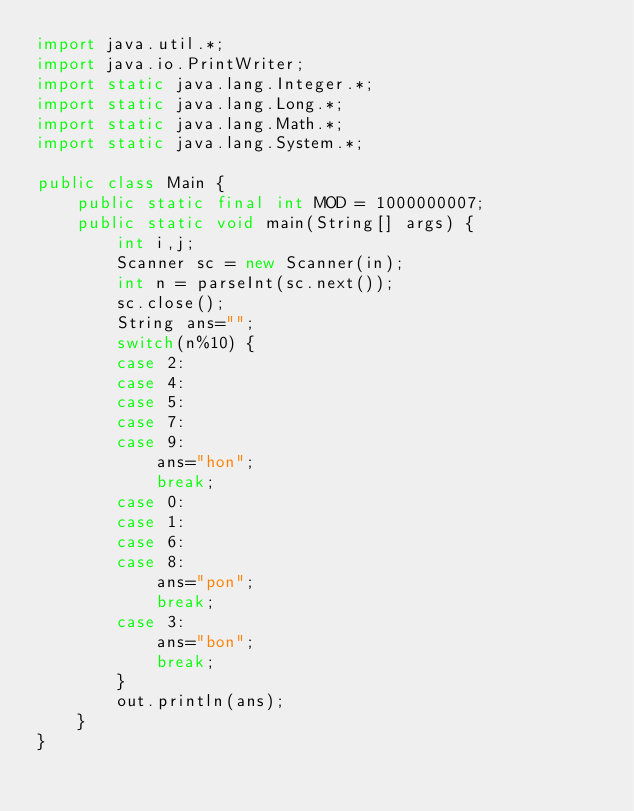Convert code to text. <code><loc_0><loc_0><loc_500><loc_500><_Java_>import java.util.*;
import java.io.PrintWriter;
import static java.lang.Integer.*;
import static java.lang.Long.*;
import static java.lang.Math.*;
import static java.lang.System.*;

public class Main {
	public static final int MOD = 1000000007;
	public static void main(String[] args) {
		int i,j;
		Scanner sc = new Scanner(in);
		int n = parseInt(sc.next());
		sc.close();
		String ans="";
		switch(n%10) {
		case 2:
		case 4:
		case 5:
		case 7:
		case 9:
			ans="hon";
			break;
		case 0:
		case 1:
		case 6:
		case 8:
			ans="pon";
			break;
		case 3:
			ans="bon";
			break;
		}
		out.println(ans);
	}
}
</code> 